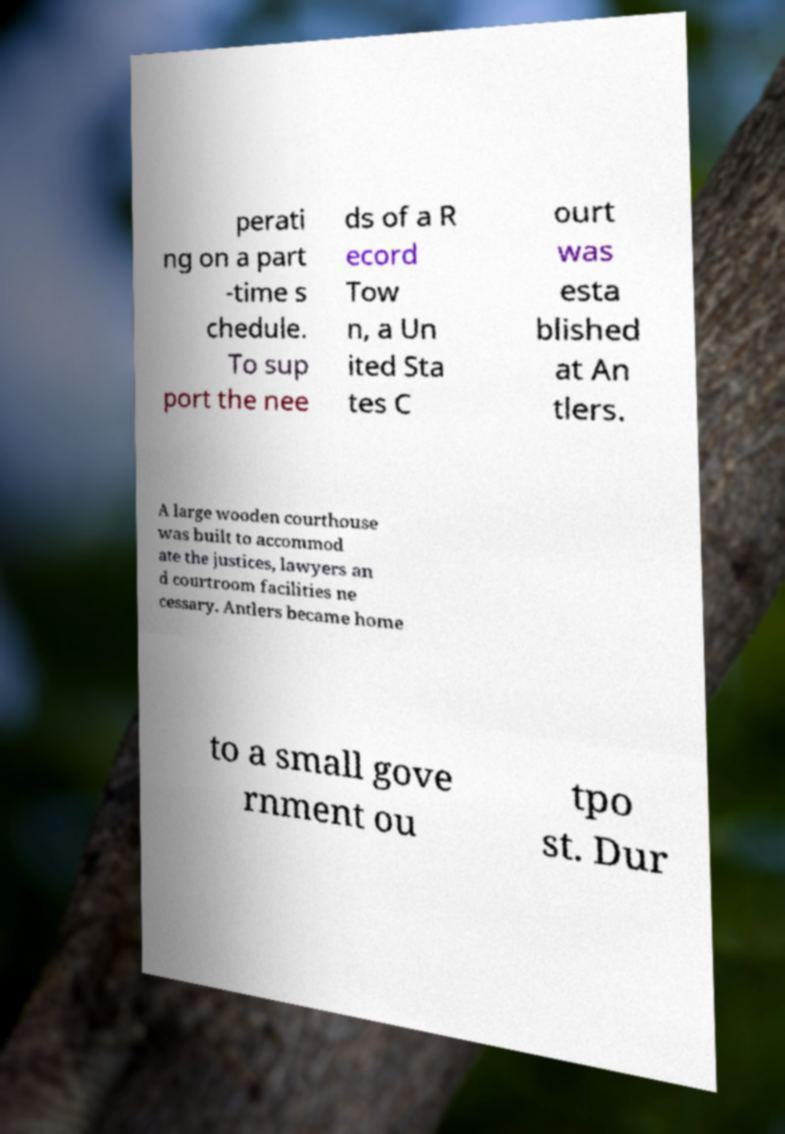Could you assist in decoding the text presented in this image and type it out clearly? perati ng on a part -time s chedule. To sup port the nee ds of a R ecord Tow n, a Un ited Sta tes C ourt was esta blished at An tlers. A large wooden courthouse was built to accommod ate the justices, lawyers an d courtroom facilities ne cessary. Antlers became home to a small gove rnment ou tpo st. Dur 